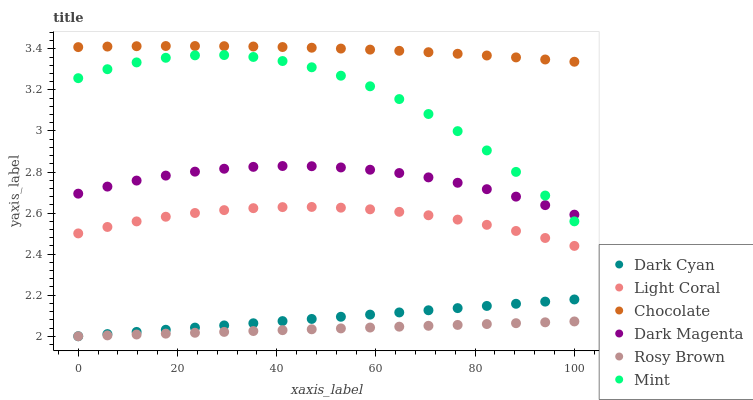Does Rosy Brown have the minimum area under the curve?
Answer yes or no. Yes. Does Chocolate have the maximum area under the curve?
Answer yes or no. Yes. Does Chocolate have the minimum area under the curve?
Answer yes or no. No. Does Rosy Brown have the maximum area under the curve?
Answer yes or no. No. Is Dark Cyan the smoothest?
Answer yes or no. Yes. Is Mint the roughest?
Answer yes or no. Yes. Is Rosy Brown the smoothest?
Answer yes or no. No. Is Rosy Brown the roughest?
Answer yes or no. No. Does Rosy Brown have the lowest value?
Answer yes or no. Yes. Does Chocolate have the lowest value?
Answer yes or no. No. Does Chocolate have the highest value?
Answer yes or no. Yes. Does Rosy Brown have the highest value?
Answer yes or no. No. Is Light Coral less than Chocolate?
Answer yes or no. Yes. Is Mint greater than Rosy Brown?
Answer yes or no. Yes. Does Rosy Brown intersect Dark Cyan?
Answer yes or no. Yes. Is Rosy Brown less than Dark Cyan?
Answer yes or no. No. Is Rosy Brown greater than Dark Cyan?
Answer yes or no. No. Does Light Coral intersect Chocolate?
Answer yes or no. No. 